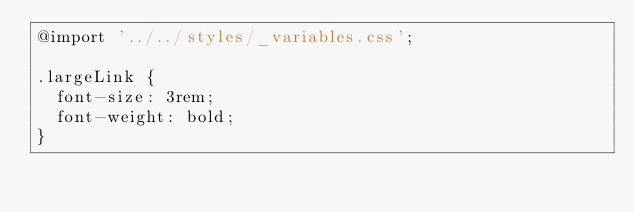<code> <loc_0><loc_0><loc_500><loc_500><_CSS_>@import '../../styles/_variables.css';

.largeLink {
  font-size: 3rem;
  font-weight: bold;
}</code> 